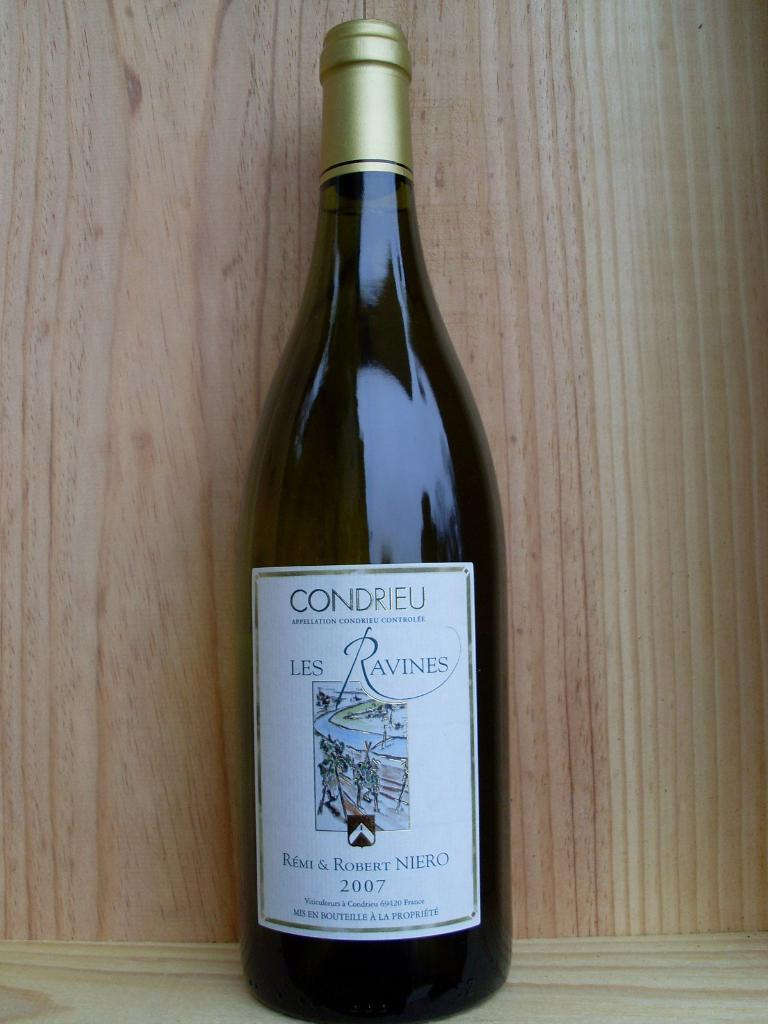What is the main object in the image? There is a wine bottle in the image. Where is the wine bottle located in relation to other objects or surfaces? The wine bottle is kept near a wooden wall or table. What type of industry can be seen operating in the background of the image? There is no industry visible in the image; it only features a wine bottle near a wooden wall or table. 